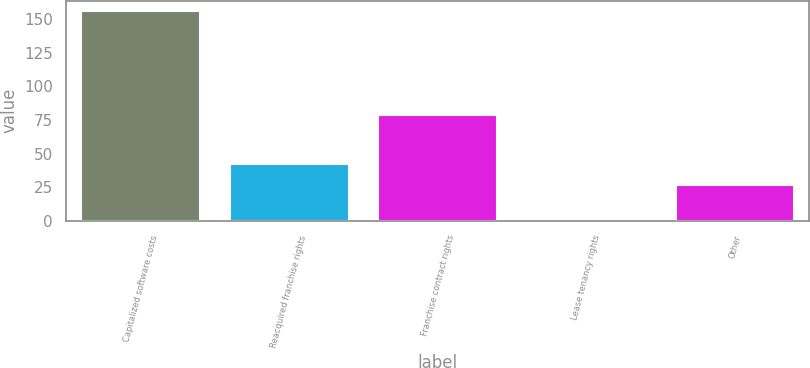Convert chart. <chart><loc_0><loc_0><loc_500><loc_500><bar_chart><fcel>Capitalized software costs<fcel>Reacquired franchise rights<fcel>Franchise contract rights<fcel>Lease tenancy rights<fcel>Other<nl><fcel>156<fcel>42.5<fcel>79<fcel>1<fcel>27<nl></chart> 